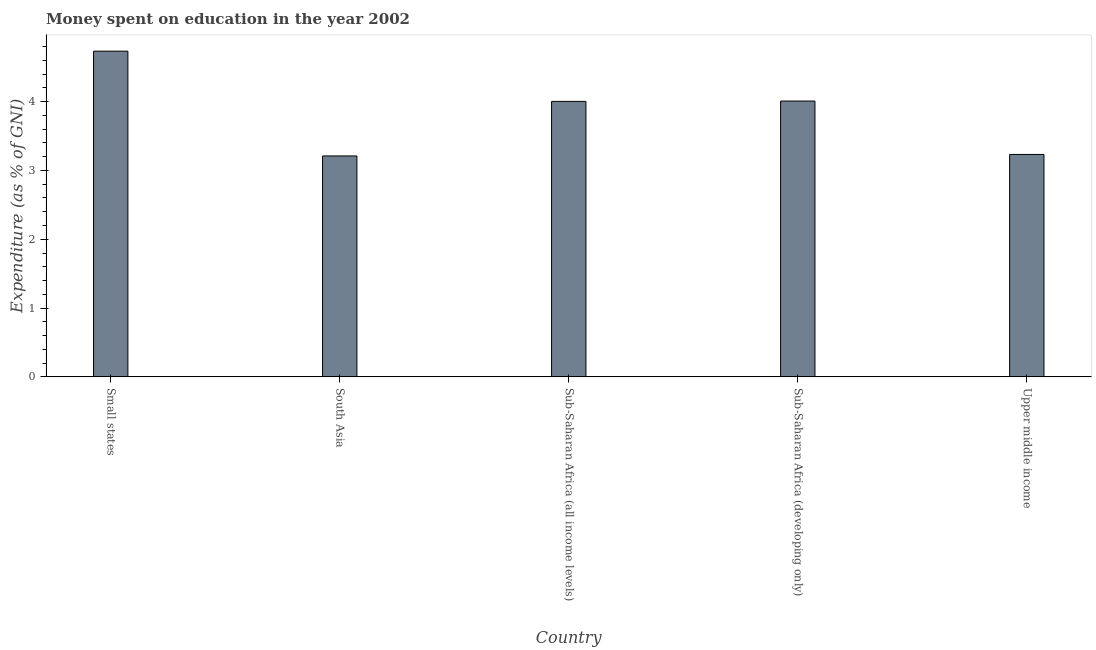Does the graph contain grids?
Offer a very short reply. No. What is the title of the graph?
Keep it short and to the point. Money spent on education in the year 2002. What is the label or title of the X-axis?
Ensure brevity in your answer.  Country. What is the label or title of the Y-axis?
Offer a very short reply. Expenditure (as % of GNI). What is the expenditure on education in Small states?
Your answer should be very brief. 4.73. Across all countries, what is the maximum expenditure on education?
Offer a very short reply. 4.73. Across all countries, what is the minimum expenditure on education?
Offer a very short reply. 3.21. In which country was the expenditure on education maximum?
Your response must be concise. Small states. What is the sum of the expenditure on education?
Your answer should be very brief. 19.19. What is the difference between the expenditure on education in Sub-Saharan Africa (developing only) and Upper middle income?
Offer a very short reply. 0.78. What is the average expenditure on education per country?
Make the answer very short. 3.84. What is the median expenditure on education?
Keep it short and to the point. 4. Is the expenditure on education in South Asia less than that in Upper middle income?
Your answer should be compact. Yes. Is the difference between the expenditure on education in Small states and Sub-Saharan Africa (all income levels) greater than the difference between any two countries?
Your answer should be very brief. No. What is the difference between the highest and the second highest expenditure on education?
Keep it short and to the point. 0.72. What is the difference between the highest and the lowest expenditure on education?
Your answer should be compact. 1.52. In how many countries, is the expenditure on education greater than the average expenditure on education taken over all countries?
Offer a very short reply. 3. Are the values on the major ticks of Y-axis written in scientific E-notation?
Give a very brief answer. No. What is the Expenditure (as % of GNI) in Small states?
Ensure brevity in your answer.  4.73. What is the Expenditure (as % of GNI) in South Asia?
Your response must be concise. 3.21. What is the Expenditure (as % of GNI) in Sub-Saharan Africa (all income levels)?
Your response must be concise. 4. What is the Expenditure (as % of GNI) in Sub-Saharan Africa (developing only)?
Your response must be concise. 4.01. What is the Expenditure (as % of GNI) of Upper middle income?
Give a very brief answer. 3.23. What is the difference between the Expenditure (as % of GNI) in Small states and South Asia?
Your answer should be compact. 1.52. What is the difference between the Expenditure (as % of GNI) in Small states and Sub-Saharan Africa (all income levels)?
Offer a terse response. 0.73. What is the difference between the Expenditure (as % of GNI) in Small states and Sub-Saharan Africa (developing only)?
Your answer should be very brief. 0.73. What is the difference between the Expenditure (as % of GNI) in Small states and Upper middle income?
Ensure brevity in your answer.  1.5. What is the difference between the Expenditure (as % of GNI) in South Asia and Sub-Saharan Africa (all income levels)?
Your response must be concise. -0.79. What is the difference between the Expenditure (as % of GNI) in South Asia and Sub-Saharan Africa (developing only)?
Your response must be concise. -0.8. What is the difference between the Expenditure (as % of GNI) in South Asia and Upper middle income?
Keep it short and to the point. -0.02. What is the difference between the Expenditure (as % of GNI) in Sub-Saharan Africa (all income levels) and Sub-Saharan Africa (developing only)?
Give a very brief answer. -0. What is the difference between the Expenditure (as % of GNI) in Sub-Saharan Africa (all income levels) and Upper middle income?
Offer a very short reply. 0.77. What is the difference between the Expenditure (as % of GNI) in Sub-Saharan Africa (developing only) and Upper middle income?
Give a very brief answer. 0.78. What is the ratio of the Expenditure (as % of GNI) in Small states to that in South Asia?
Provide a succinct answer. 1.47. What is the ratio of the Expenditure (as % of GNI) in Small states to that in Sub-Saharan Africa (all income levels)?
Your answer should be compact. 1.18. What is the ratio of the Expenditure (as % of GNI) in Small states to that in Sub-Saharan Africa (developing only)?
Make the answer very short. 1.18. What is the ratio of the Expenditure (as % of GNI) in Small states to that in Upper middle income?
Your response must be concise. 1.46. What is the ratio of the Expenditure (as % of GNI) in South Asia to that in Sub-Saharan Africa (all income levels)?
Provide a succinct answer. 0.8. What is the ratio of the Expenditure (as % of GNI) in South Asia to that in Sub-Saharan Africa (developing only)?
Offer a terse response. 0.8. What is the ratio of the Expenditure (as % of GNI) in Sub-Saharan Africa (all income levels) to that in Upper middle income?
Provide a succinct answer. 1.24. What is the ratio of the Expenditure (as % of GNI) in Sub-Saharan Africa (developing only) to that in Upper middle income?
Ensure brevity in your answer.  1.24. 